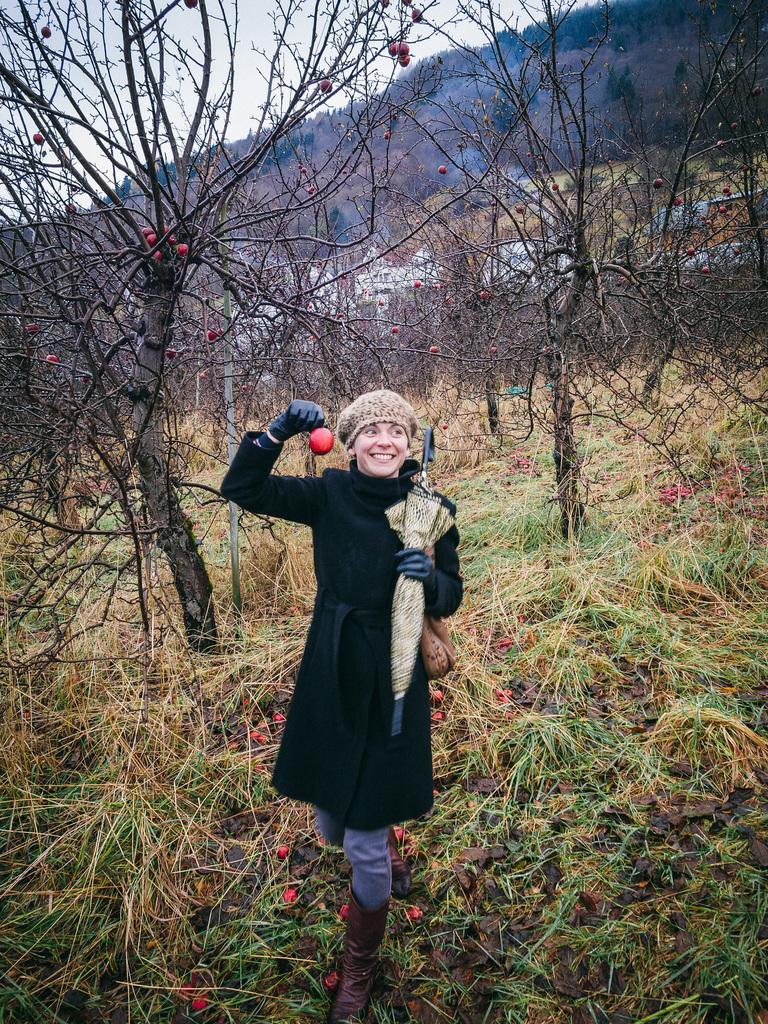How would you summarize this image in a sentence or two? In this picture there is a woman who is wearing gloves, cap, jacket, jeans and shoes. She is holding an umbrella and apple. She is standing on the grass. Beside her I can see the apple trees. In the background I can see many trees on the mountain and buildings. At the top I can see the sky. 